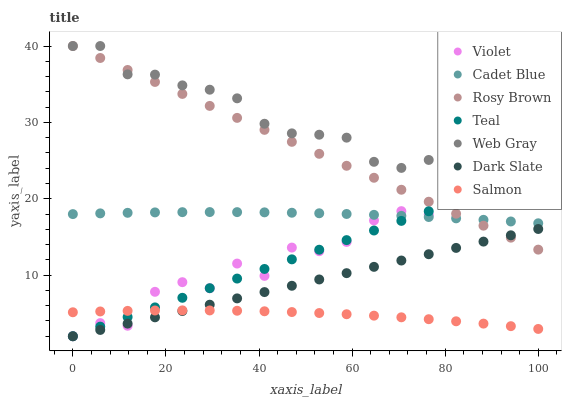Does Salmon have the minimum area under the curve?
Answer yes or no. Yes. Does Web Gray have the maximum area under the curve?
Answer yes or no. Yes. Does Rosy Brown have the minimum area under the curve?
Answer yes or no. No. Does Rosy Brown have the maximum area under the curve?
Answer yes or no. No. Is Dark Slate the smoothest?
Answer yes or no. Yes. Is Violet the roughest?
Answer yes or no. Yes. Is Rosy Brown the smoothest?
Answer yes or no. No. Is Rosy Brown the roughest?
Answer yes or no. No. Does Dark Slate have the lowest value?
Answer yes or no. Yes. Does Rosy Brown have the lowest value?
Answer yes or no. No. Does Web Gray have the highest value?
Answer yes or no. Yes. Does Salmon have the highest value?
Answer yes or no. No. Is Salmon less than Web Gray?
Answer yes or no. Yes. Is Web Gray greater than Salmon?
Answer yes or no. Yes. Does Dark Slate intersect Rosy Brown?
Answer yes or no. Yes. Is Dark Slate less than Rosy Brown?
Answer yes or no. No. Is Dark Slate greater than Rosy Brown?
Answer yes or no. No. Does Salmon intersect Web Gray?
Answer yes or no. No. 